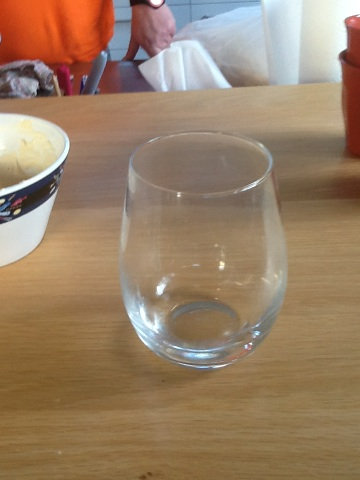What types of beverages would be suitable to serve in this type of glass? This type of wine glass is versatile. It is most suitable for serving white wines, which are typically enjoyed chilled. However, it could also be used for certain red varieties or even creative cocktails. 